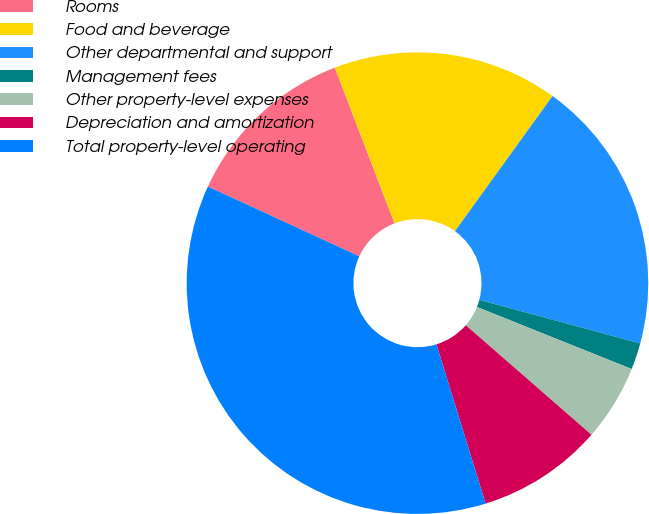Convert chart to OTSL. <chart><loc_0><loc_0><loc_500><loc_500><pie_chart><fcel>Rooms<fcel>Food and beverage<fcel>Other departmental and support<fcel>Management fees<fcel>Other property-level expenses<fcel>Depreciation and amortization<fcel>Total property-level operating<nl><fcel>12.3%<fcel>15.78%<fcel>19.26%<fcel>1.86%<fcel>5.34%<fcel>8.82%<fcel>36.65%<nl></chart> 